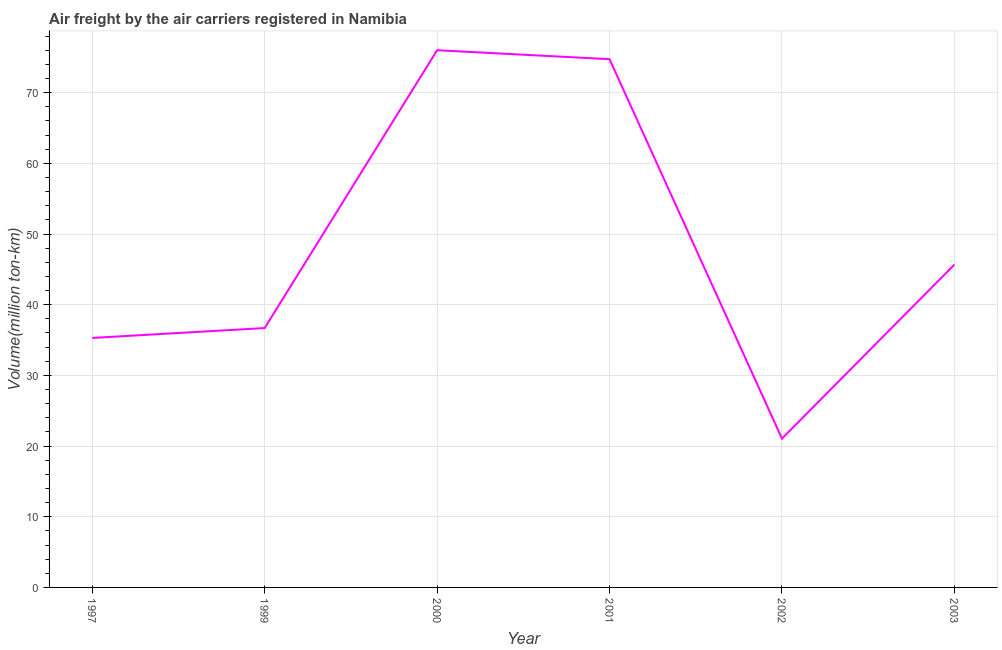What is the air freight in 2003?
Keep it short and to the point. 45.67. Across all years, what is the maximum air freight?
Your answer should be very brief. 76.01. Across all years, what is the minimum air freight?
Your response must be concise. 21.06. In which year was the air freight maximum?
Offer a terse response. 2000. In which year was the air freight minimum?
Your answer should be very brief. 2002. What is the sum of the air freight?
Offer a terse response. 289.49. What is the difference between the air freight in 1999 and 2003?
Give a very brief answer. -8.97. What is the average air freight per year?
Offer a very short reply. 48.25. What is the median air freight?
Make the answer very short. 41.19. Do a majority of the years between 2001 and 1999 (inclusive) have air freight greater than 2 million ton-km?
Your response must be concise. No. What is the ratio of the air freight in 1997 to that in 2001?
Ensure brevity in your answer.  0.47. Is the air freight in 1997 less than that in 2002?
Make the answer very short. No. What is the difference between the highest and the second highest air freight?
Your answer should be very brief. 1.26. Is the sum of the air freight in 1997 and 2003 greater than the maximum air freight across all years?
Offer a terse response. Yes. What is the difference between the highest and the lowest air freight?
Your answer should be compact. 54.95. How many years are there in the graph?
Offer a terse response. 6. Are the values on the major ticks of Y-axis written in scientific E-notation?
Offer a very short reply. No. Does the graph contain any zero values?
Keep it short and to the point. No. What is the title of the graph?
Your answer should be very brief. Air freight by the air carriers registered in Namibia. What is the label or title of the Y-axis?
Your answer should be compact. Volume(million ton-km). What is the Volume(million ton-km) of 1997?
Provide a succinct answer. 35.3. What is the Volume(million ton-km) in 1999?
Provide a succinct answer. 36.7. What is the Volume(million ton-km) of 2000?
Provide a short and direct response. 76.01. What is the Volume(million ton-km) of 2001?
Give a very brief answer. 74.74. What is the Volume(million ton-km) of 2002?
Offer a terse response. 21.06. What is the Volume(million ton-km) of 2003?
Offer a very short reply. 45.67. What is the difference between the Volume(million ton-km) in 1997 and 1999?
Give a very brief answer. -1.4. What is the difference between the Volume(million ton-km) in 1997 and 2000?
Keep it short and to the point. -40.71. What is the difference between the Volume(million ton-km) in 1997 and 2001?
Your response must be concise. -39.44. What is the difference between the Volume(million ton-km) in 1997 and 2002?
Ensure brevity in your answer.  14.24. What is the difference between the Volume(million ton-km) in 1997 and 2003?
Give a very brief answer. -10.38. What is the difference between the Volume(million ton-km) in 1999 and 2000?
Ensure brevity in your answer.  -39.31. What is the difference between the Volume(million ton-km) in 1999 and 2001?
Your answer should be very brief. -38.04. What is the difference between the Volume(million ton-km) in 1999 and 2002?
Offer a very short reply. 15.64. What is the difference between the Volume(million ton-km) in 1999 and 2003?
Provide a succinct answer. -8.97. What is the difference between the Volume(million ton-km) in 2000 and 2001?
Give a very brief answer. 1.26. What is the difference between the Volume(million ton-km) in 2000 and 2002?
Your answer should be compact. 54.95. What is the difference between the Volume(million ton-km) in 2000 and 2003?
Provide a short and direct response. 30.33. What is the difference between the Volume(million ton-km) in 2001 and 2002?
Offer a terse response. 53.69. What is the difference between the Volume(million ton-km) in 2001 and 2003?
Offer a terse response. 29.07. What is the difference between the Volume(million ton-km) in 2002 and 2003?
Your answer should be compact. -24.62. What is the ratio of the Volume(million ton-km) in 1997 to that in 1999?
Your answer should be compact. 0.96. What is the ratio of the Volume(million ton-km) in 1997 to that in 2000?
Provide a short and direct response. 0.46. What is the ratio of the Volume(million ton-km) in 1997 to that in 2001?
Your answer should be compact. 0.47. What is the ratio of the Volume(million ton-km) in 1997 to that in 2002?
Your answer should be compact. 1.68. What is the ratio of the Volume(million ton-km) in 1997 to that in 2003?
Provide a short and direct response. 0.77. What is the ratio of the Volume(million ton-km) in 1999 to that in 2000?
Give a very brief answer. 0.48. What is the ratio of the Volume(million ton-km) in 1999 to that in 2001?
Keep it short and to the point. 0.49. What is the ratio of the Volume(million ton-km) in 1999 to that in 2002?
Make the answer very short. 1.74. What is the ratio of the Volume(million ton-km) in 1999 to that in 2003?
Your answer should be very brief. 0.8. What is the ratio of the Volume(million ton-km) in 2000 to that in 2001?
Provide a succinct answer. 1.02. What is the ratio of the Volume(million ton-km) in 2000 to that in 2002?
Keep it short and to the point. 3.61. What is the ratio of the Volume(million ton-km) in 2000 to that in 2003?
Offer a very short reply. 1.66. What is the ratio of the Volume(million ton-km) in 2001 to that in 2002?
Offer a very short reply. 3.55. What is the ratio of the Volume(million ton-km) in 2001 to that in 2003?
Your answer should be compact. 1.64. What is the ratio of the Volume(million ton-km) in 2002 to that in 2003?
Provide a succinct answer. 0.46. 